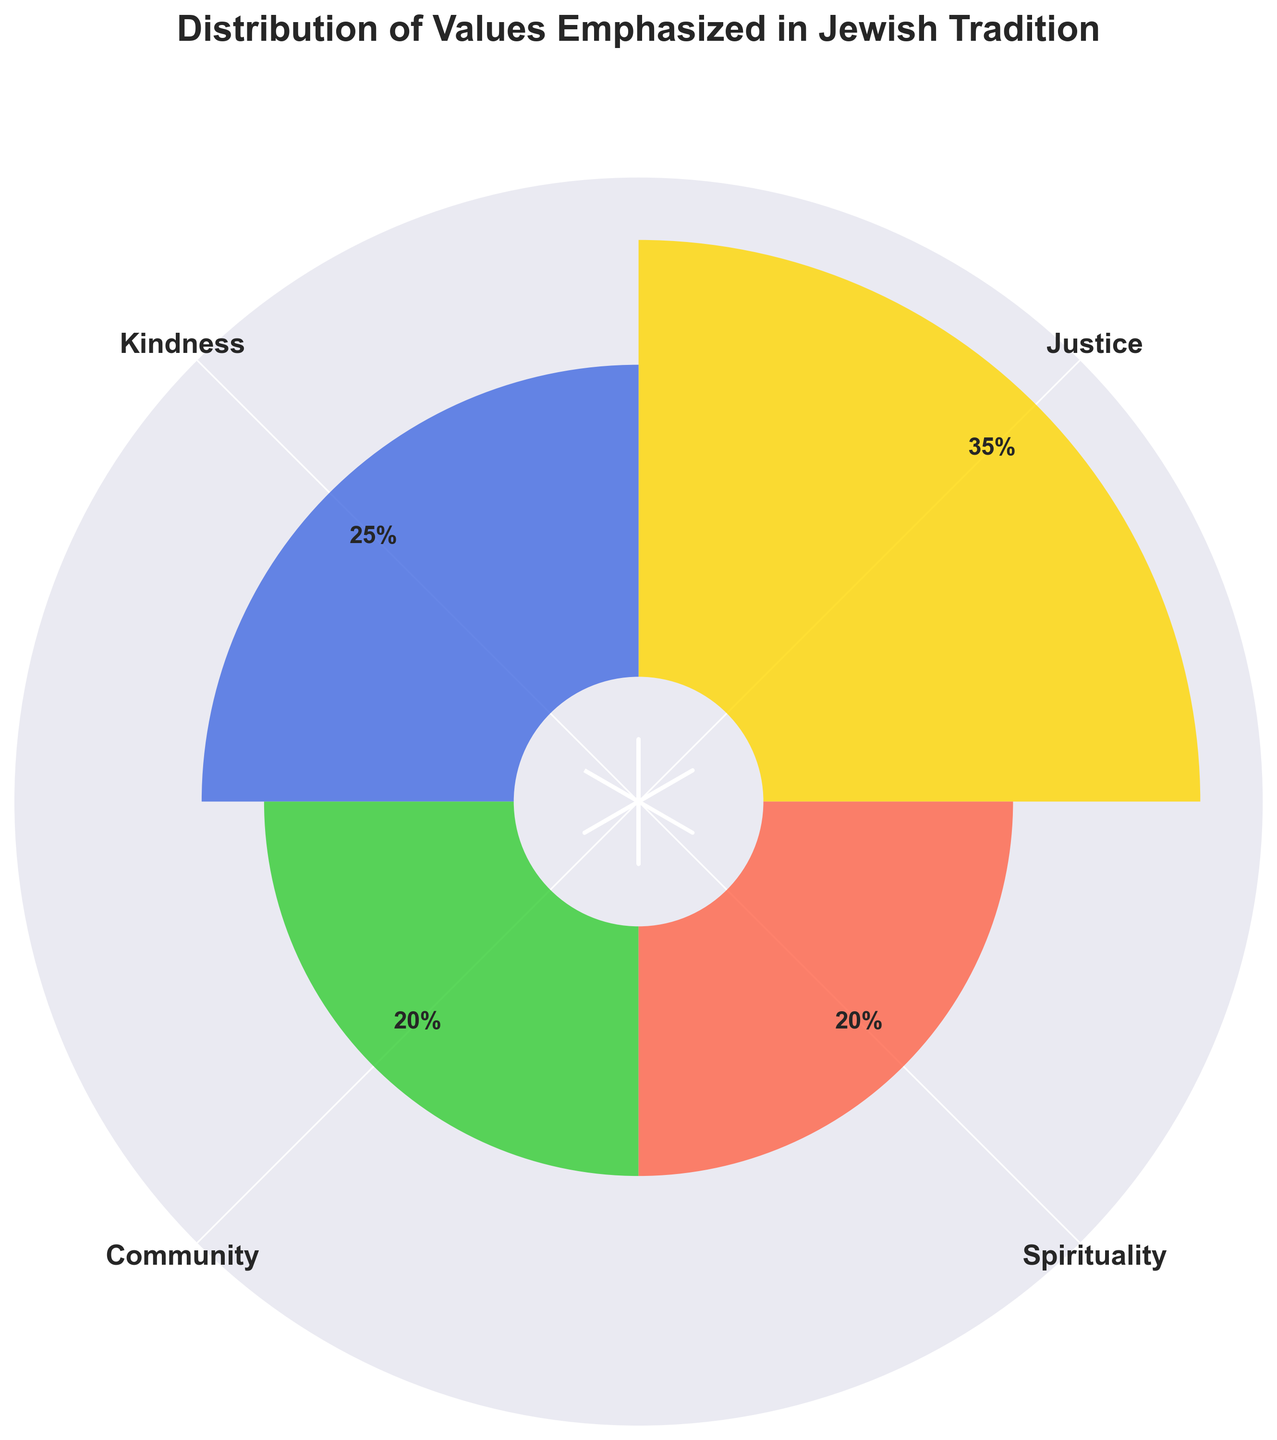What is the title of the plot? The title is usually located at the top of the plot. In this case, the title reads "Distribution of Values Emphasized in Jewish Tradition."
Answer: Distribution of Values Emphasized in Jewish Tradition Which value has the highest percentage? By looking at the length of the bars in the chart, the bar representing "Justice" is the longest. The percentage label for Justice is 35%.
Answer: Justice What are the colors associated with each value? The colors are visually distinct in the plot. Justice is represented by gold, Kindness by dark blue, Community by green, and Spirituality by red.
Answer: Gold for Justice, Dark Blue for Kindness, Green for Community, Red for Spirituality How many values have the same percentage? By observing the percentage labels, both Community and Spirituality have the same percentage of 20%.
Answer: Two What is the sum of the percentages for Kindness and Spirituality? Kindness has a percentage of 25%, and Spirituality has 20%. Adding these together: 25% + 20% = 45%.
Answer: 45% Which value has the smallest percentage and what is it? By examining the plot, both Community and Spirituality have the smallest and equal percentages of 20%.
Answer: Community, Spirituality What is the difference in percentage between Justice and Community? The percentage for Justice is 35%, and for Community, it is 20%. Subtracting these gives: 35% - 20% = 15%.
Answer: 15% Among Justice and Kindness, which has a lower percentage and by how much? Justice is 35%, and Kindness is 25%. The difference is calculated by: 35% - 25% = 10%.
Answer: Kindness by 10% Is the sum of the percentages of Justice and Kindness greater than 50%? Summing the percentages for Justice (35%) and Kindness (25%) gives 60%. Since 60% > 50%, the answer is yes.
Answer: Yes In the polar plot, what is the radial distance at which the percentage labels are placed? The labels are placed 5 units above the respective bars. Since the bars have varying lengths based on their percentage, the labels for each are at their percentage value + 5 units.
Answer: 5 units above each bar 